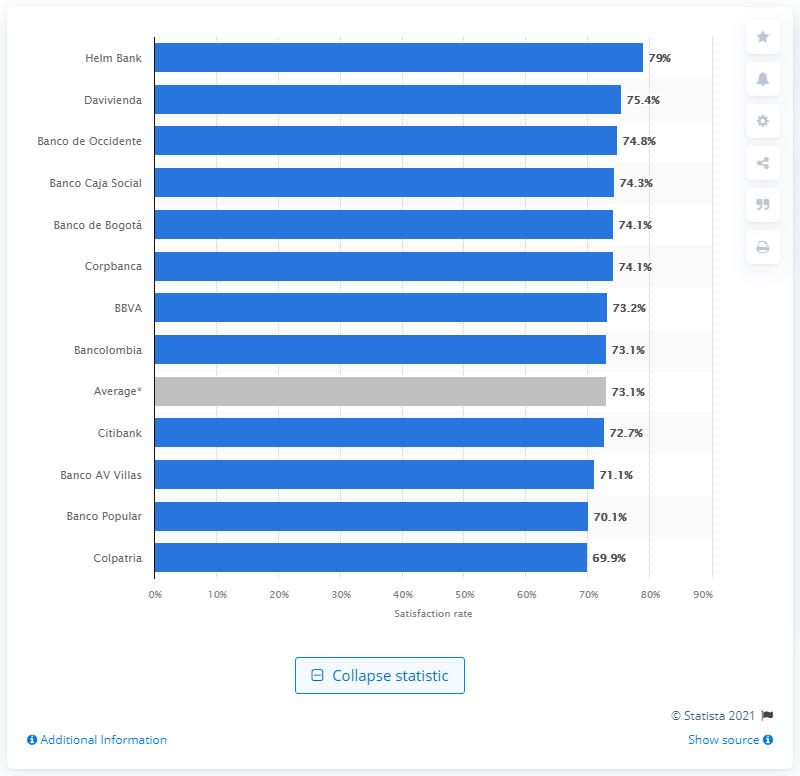Indicate a few pertinent items in this graphic. The industry average customer satisfaction rate in Colombia was 73.2% in 2015, indicating a general satisfaction with the services provided by companies in the industry. 